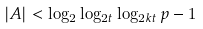Convert formula to latex. <formula><loc_0><loc_0><loc_500><loc_500>| A | < \log _ { 2 } \log _ { 2 t } \log _ { 2 k t } p - 1</formula> 